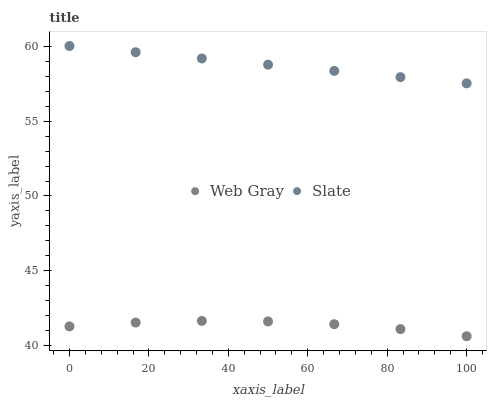Does Web Gray have the minimum area under the curve?
Answer yes or no. Yes. Does Slate have the maximum area under the curve?
Answer yes or no. Yes. Does Web Gray have the maximum area under the curve?
Answer yes or no. No. Is Slate the smoothest?
Answer yes or no. Yes. Is Web Gray the roughest?
Answer yes or no. Yes. Is Web Gray the smoothest?
Answer yes or no. No. Does Web Gray have the lowest value?
Answer yes or no. Yes. Does Slate have the highest value?
Answer yes or no. Yes. Does Web Gray have the highest value?
Answer yes or no. No. Is Web Gray less than Slate?
Answer yes or no. Yes. Is Slate greater than Web Gray?
Answer yes or no. Yes. Does Web Gray intersect Slate?
Answer yes or no. No. 